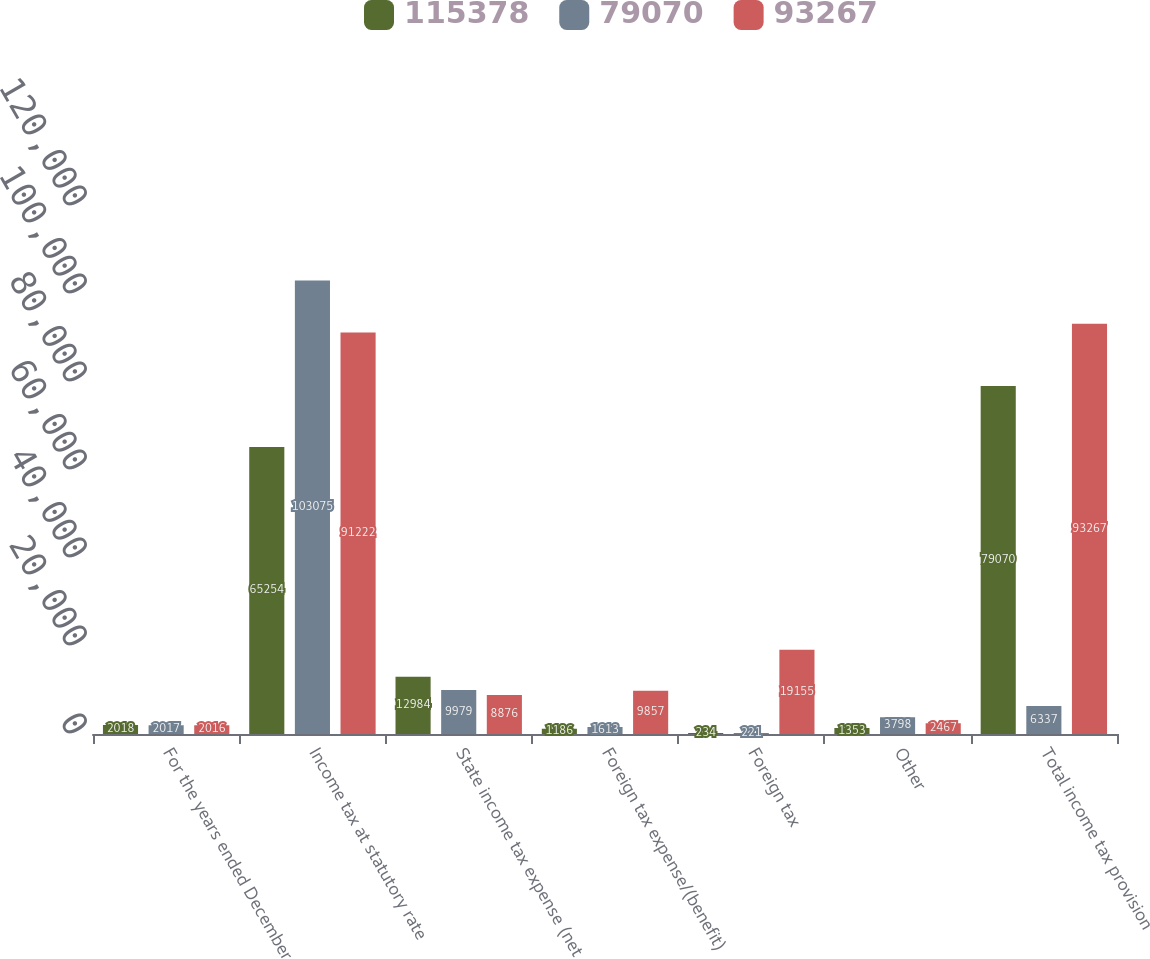Convert chart. <chart><loc_0><loc_0><loc_500><loc_500><stacked_bar_chart><ecel><fcel>For the years ended December<fcel>Income tax at statutory rate<fcel>State income tax expense (net<fcel>Foreign tax expense/(benefit)<fcel>Foreign tax<fcel>Other<fcel>Total income tax provision<nl><fcel>115378<fcel>2018<fcel>65254<fcel>12984<fcel>1186<fcel>234<fcel>1353<fcel>79070<nl><fcel>79070<fcel>2017<fcel>103075<fcel>9979<fcel>1613<fcel>221<fcel>3798<fcel>6337<nl><fcel>93267<fcel>2016<fcel>91222<fcel>8876<fcel>9857<fcel>19155<fcel>2467<fcel>93267<nl></chart> 